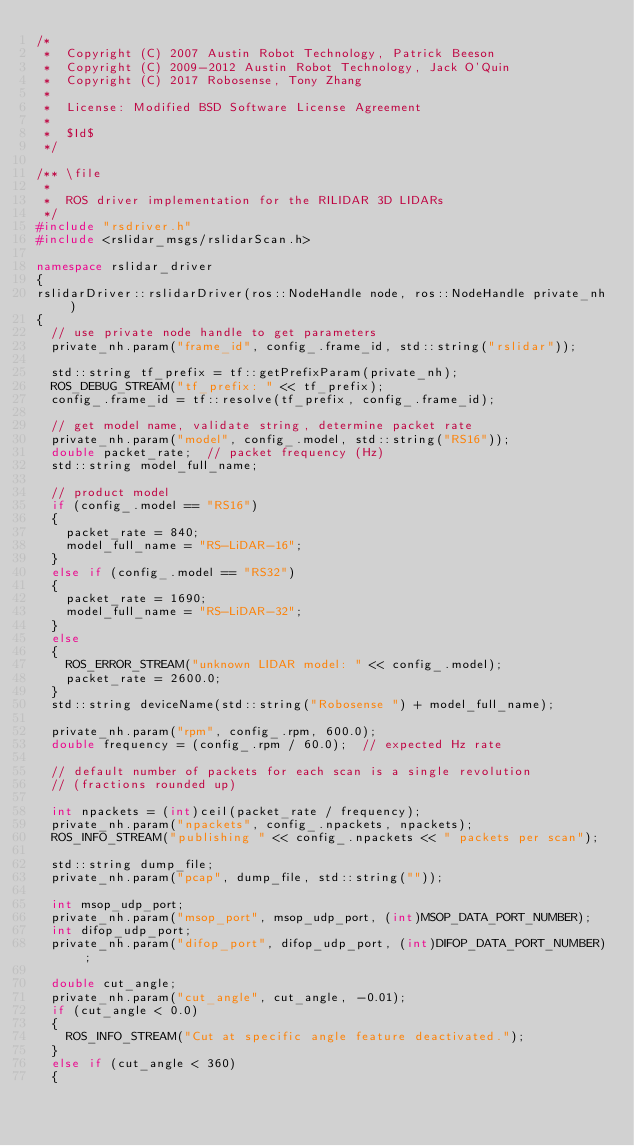Convert code to text. <code><loc_0><loc_0><loc_500><loc_500><_C++_>/*
 *  Copyright (C) 2007 Austin Robot Technology, Patrick Beeson
 *  Copyright (C) 2009-2012 Austin Robot Technology, Jack O'Quin
 *	Copyright (C) 2017 Robosense, Tony Zhang
 *
 *  License: Modified BSD Software License Agreement
 *
 *  $Id$
 */

/** \file
 *
 *  ROS driver implementation for the RILIDAR 3D LIDARs
 */
#include "rsdriver.h"
#include <rslidar_msgs/rslidarScan.h>

namespace rslidar_driver
{
rslidarDriver::rslidarDriver(ros::NodeHandle node, ros::NodeHandle private_nh)
{
  // use private node handle to get parameters
  private_nh.param("frame_id", config_.frame_id, std::string("rslidar"));

  std::string tf_prefix = tf::getPrefixParam(private_nh);
  ROS_DEBUG_STREAM("tf_prefix: " << tf_prefix);
  config_.frame_id = tf::resolve(tf_prefix, config_.frame_id);

  // get model name, validate string, determine packet rate
  private_nh.param("model", config_.model, std::string("RS16"));
  double packet_rate;  // packet frequency (Hz)
  std::string model_full_name;

  // product model
  if (config_.model == "RS16")
  {
    packet_rate = 840;
    model_full_name = "RS-LiDAR-16";
  }
  else if (config_.model == "RS32")
  {
    packet_rate = 1690;
    model_full_name = "RS-LiDAR-32";
  }
  else
  {
    ROS_ERROR_STREAM("unknown LIDAR model: " << config_.model);
    packet_rate = 2600.0;
  }
  std::string deviceName(std::string("Robosense ") + model_full_name);

  private_nh.param("rpm", config_.rpm, 600.0);
  double frequency = (config_.rpm / 60.0);  // expected Hz rate

  // default number of packets for each scan is a single revolution
  // (fractions rounded up)

  int npackets = (int)ceil(packet_rate / frequency);
  private_nh.param("npackets", config_.npackets, npackets);
  ROS_INFO_STREAM("publishing " << config_.npackets << " packets per scan");

  std::string dump_file;
  private_nh.param("pcap", dump_file, std::string(""));

  int msop_udp_port;
  private_nh.param("msop_port", msop_udp_port, (int)MSOP_DATA_PORT_NUMBER);
  int difop_udp_port;
  private_nh.param("difop_port", difop_udp_port, (int)DIFOP_DATA_PORT_NUMBER);

  double cut_angle;
  private_nh.param("cut_angle", cut_angle, -0.01);
  if (cut_angle < 0.0)
  {
    ROS_INFO_STREAM("Cut at specific angle feature deactivated.");
  }
  else if (cut_angle < 360)
  {</code> 